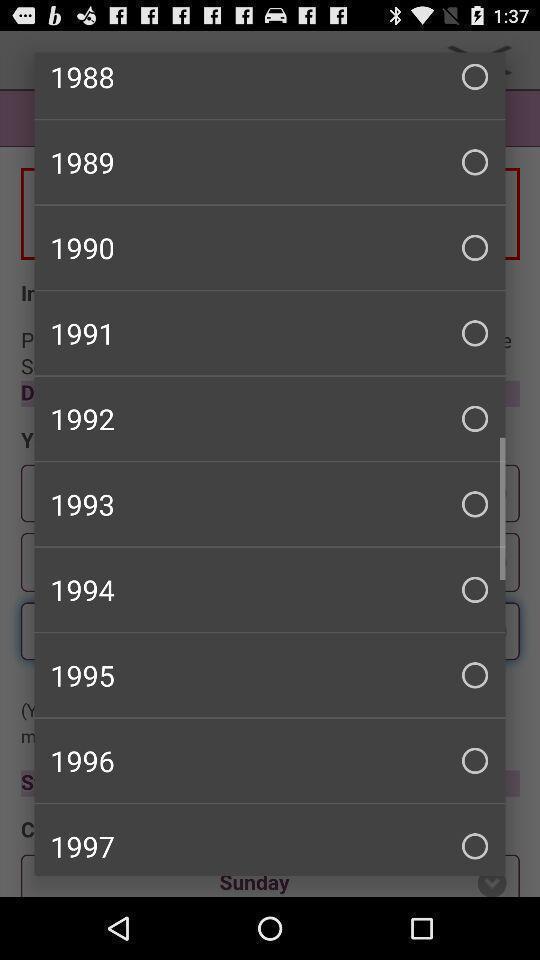Please provide a description for this image. Popup displaying list of years in a fertility tracking application. 